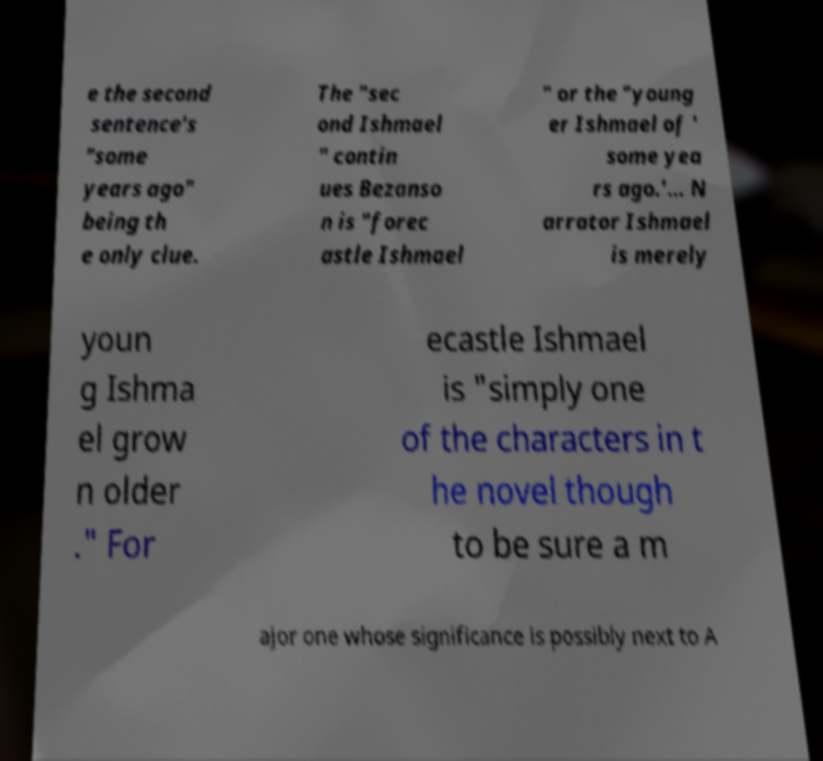For documentation purposes, I need the text within this image transcribed. Could you provide that? e the second sentence's "some years ago" being th e only clue. The "sec ond Ishmael " contin ues Bezanso n is "forec astle Ishmael " or the "young er Ishmael of ' some yea rs ago.'... N arrator Ishmael is merely youn g Ishma el grow n older ." For ecastle Ishmael is "simply one of the characters in t he novel though to be sure a m ajor one whose significance is possibly next to A 